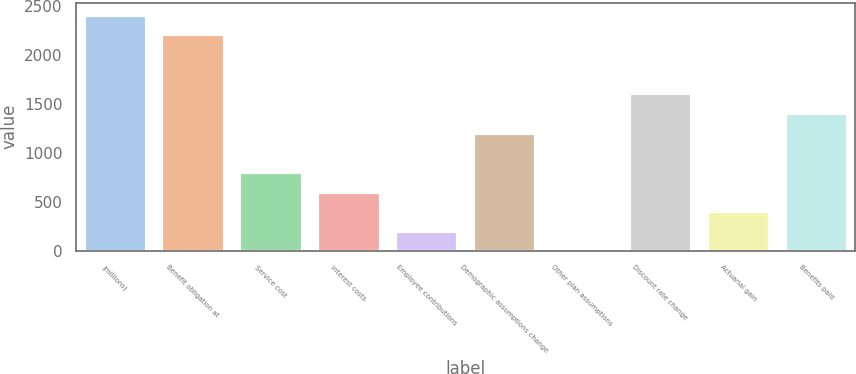<chart> <loc_0><loc_0><loc_500><loc_500><bar_chart><fcel>(millions)<fcel>Benefit obligation at<fcel>Service cost<fcel>Interest costs<fcel>Employee contributions<fcel>Demographic assumptions change<fcel>Other plan assumptions<fcel>Discount rate change<fcel>Actuarial gain<fcel>Benefits paid<nl><fcel>2415.3<fcel>2214.15<fcel>806.1<fcel>604.95<fcel>202.65<fcel>1208.4<fcel>1.5<fcel>1610.7<fcel>403.8<fcel>1409.55<nl></chart> 